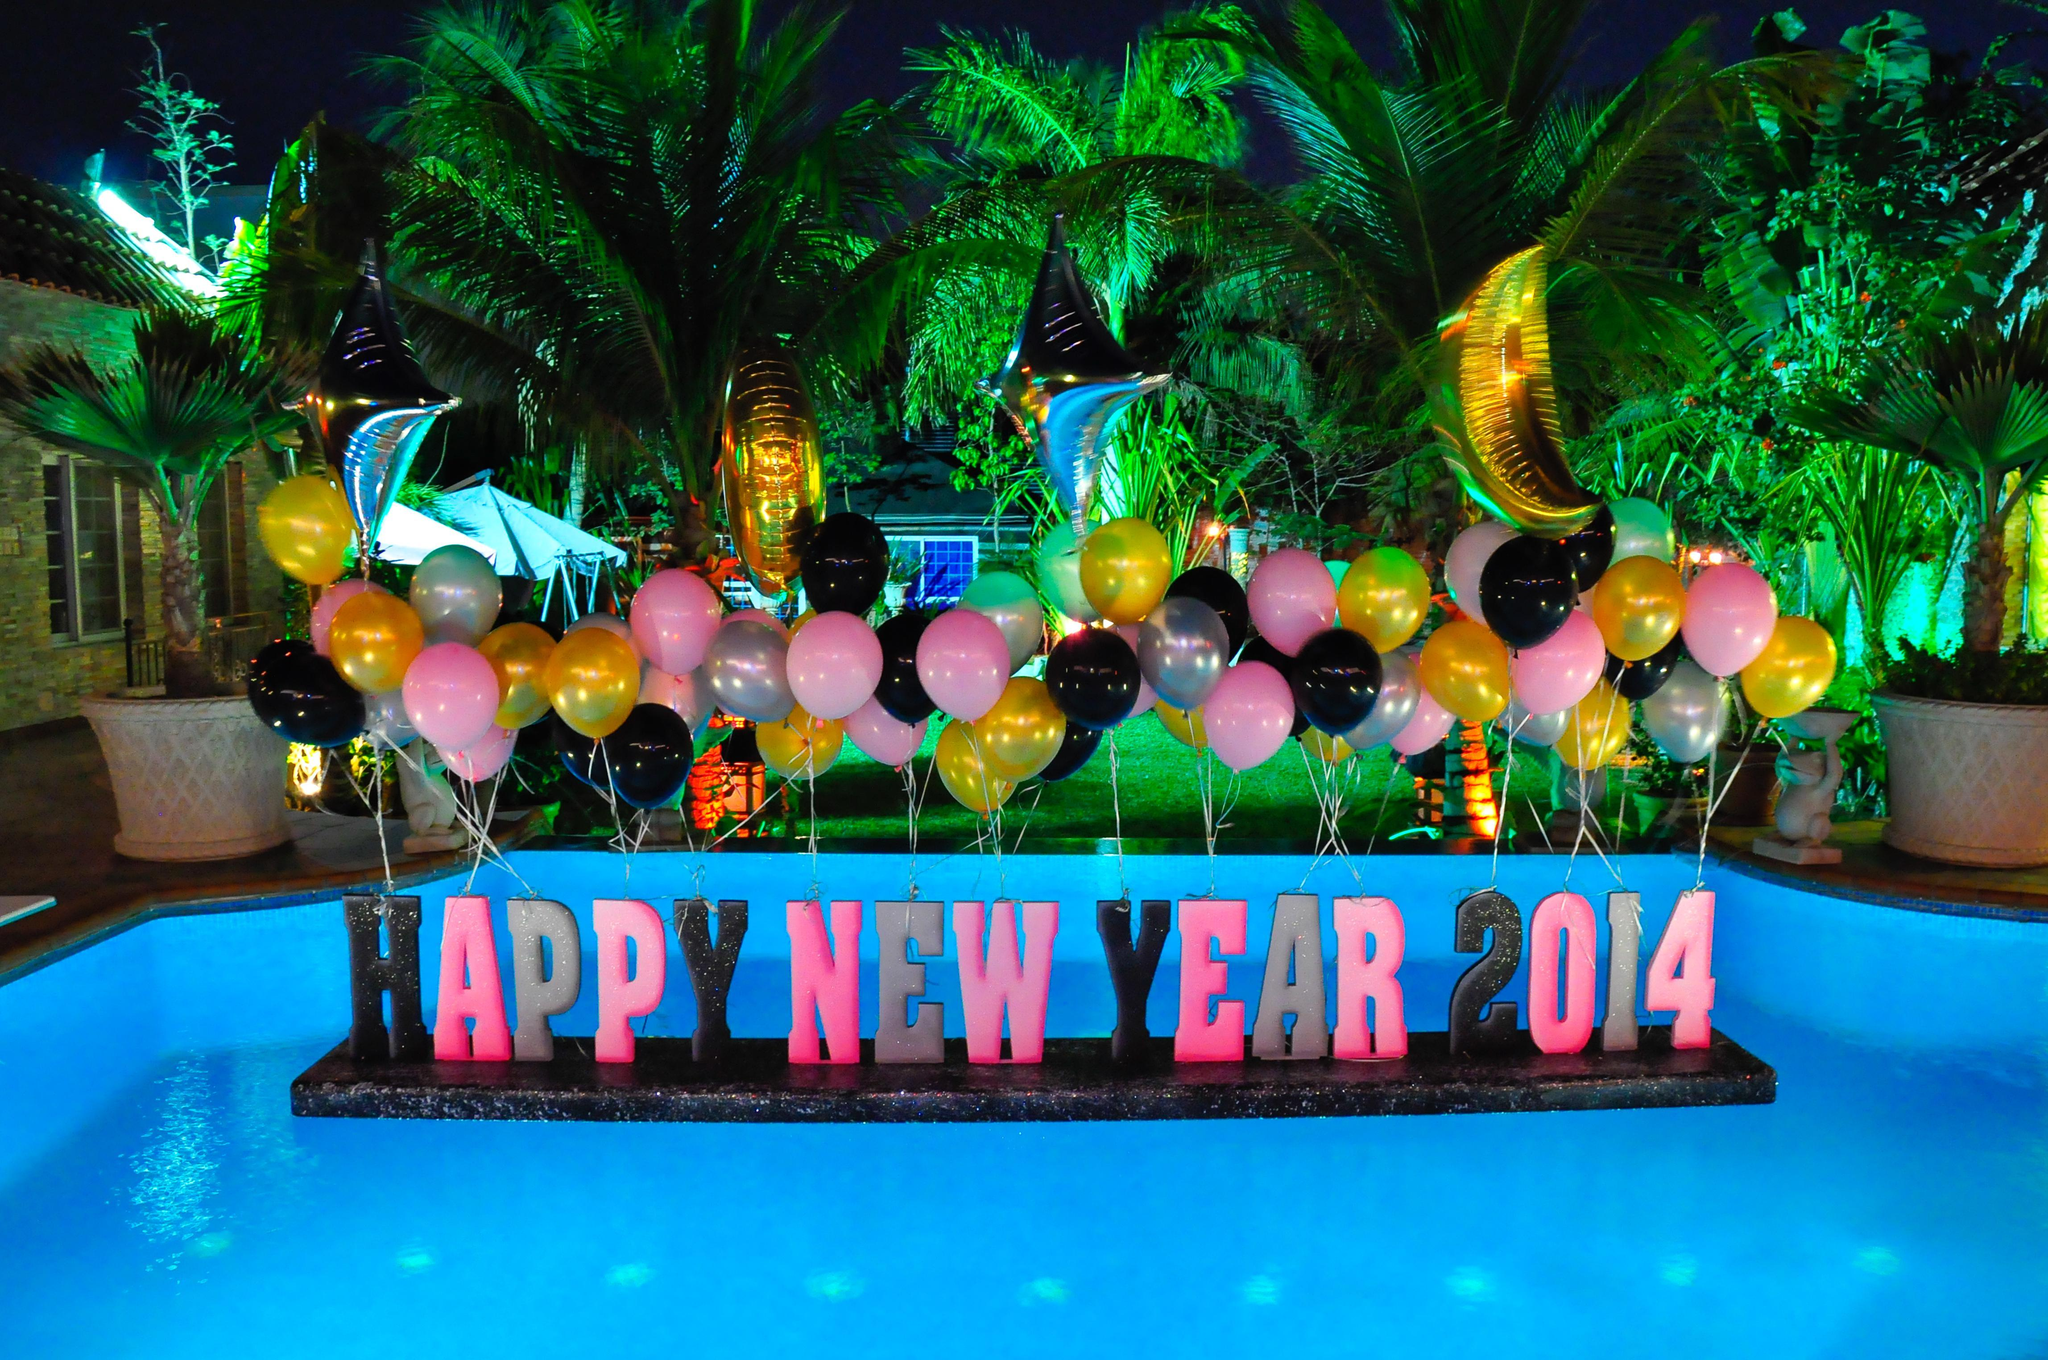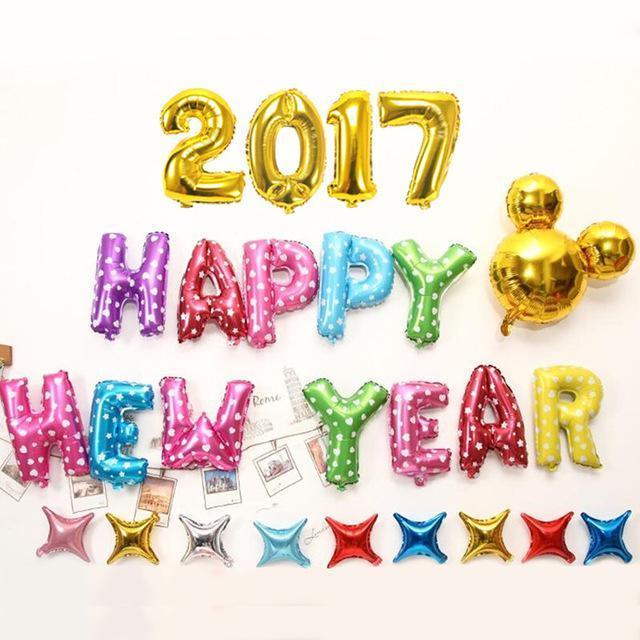The first image is the image on the left, the second image is the image on the right. Assess this claim about the two images: "Both images have letters.". Correct or not? Answer yes or no. Yes. The first image is the image on the left, the second image is the image on the right. For the images displayed, is the sentence "Some balloons have faces." factually correct? Answer yes or no. No. 